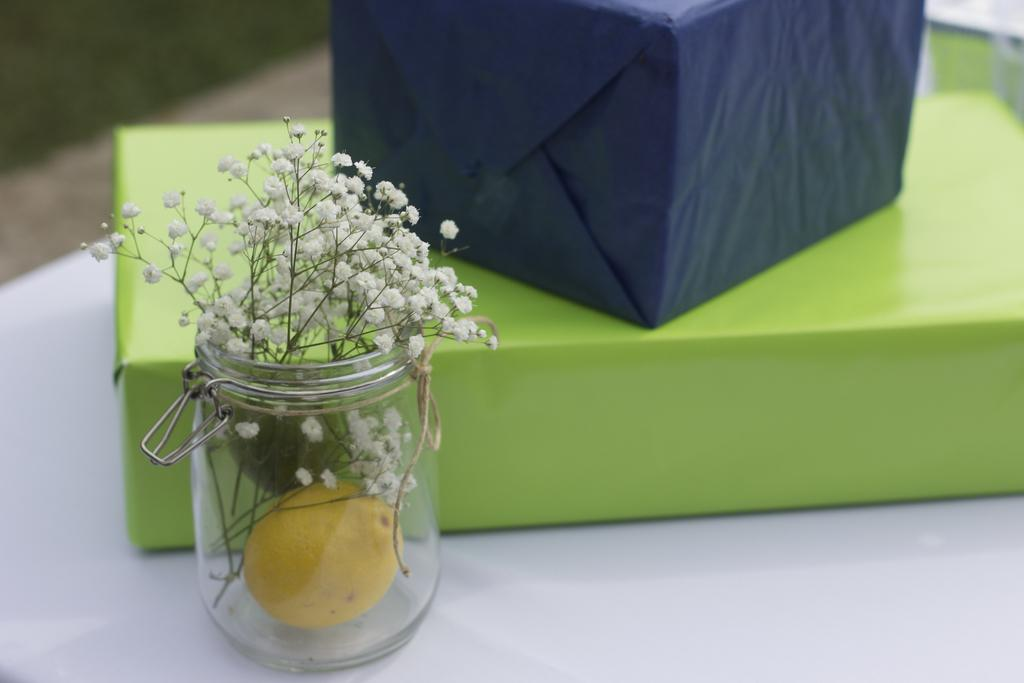What type of plants are visible in the image? There are flowers in the image. What is inside the jar in the image? There is a lemon in a jar in the image. What objects are located beside the jar in the image? There are boxes beside the jar in the image. Can you describe the man's facial expression as he turns on the faucet in the image? There is no man or faucet present in the image. What is the color of the mouth of the person holding the lemon? There is no person holding the lemon in the image. 